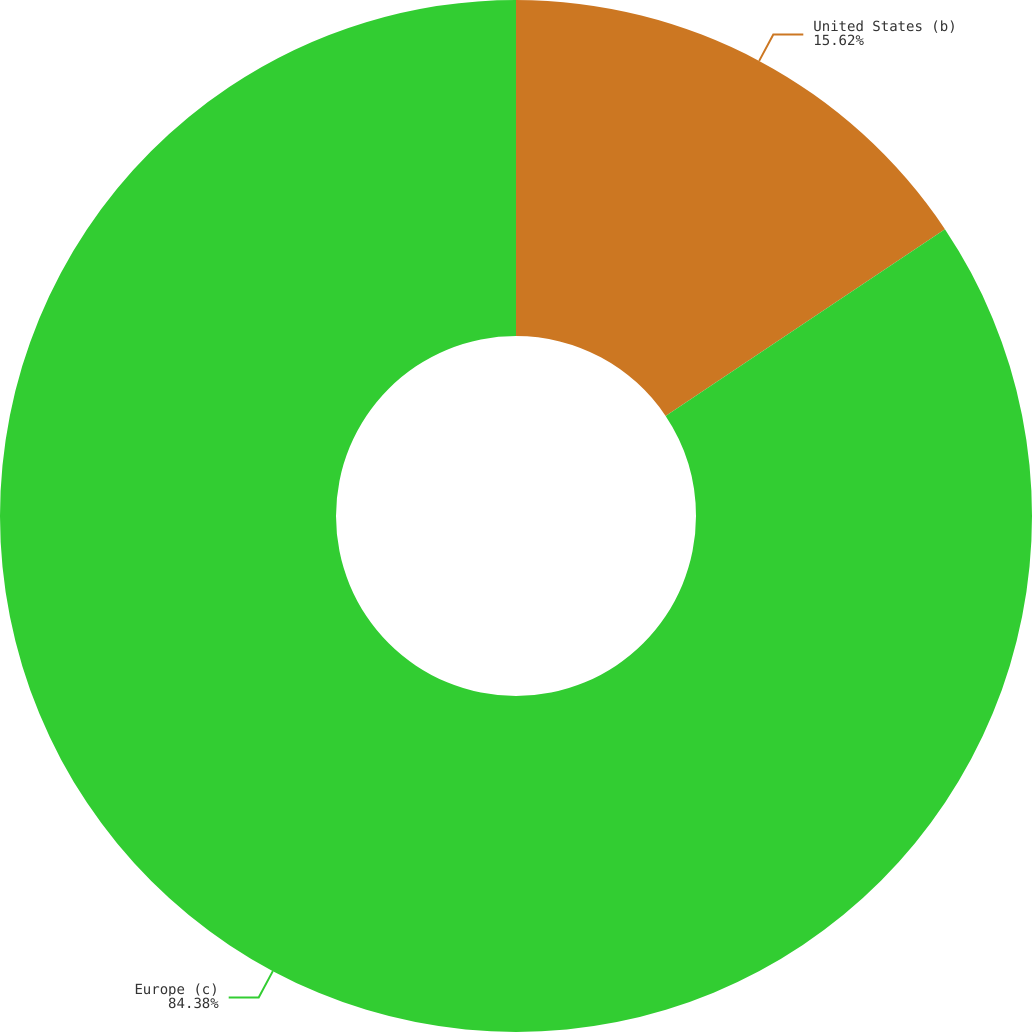Convert chart. <chart><loc_0><loc_0><loc_500><loc_500><pie_chart><fcel>United States (b)<fcel>Europe (c)<nl><fcel>15.62%<fcel>84.38%<nl></chart> 